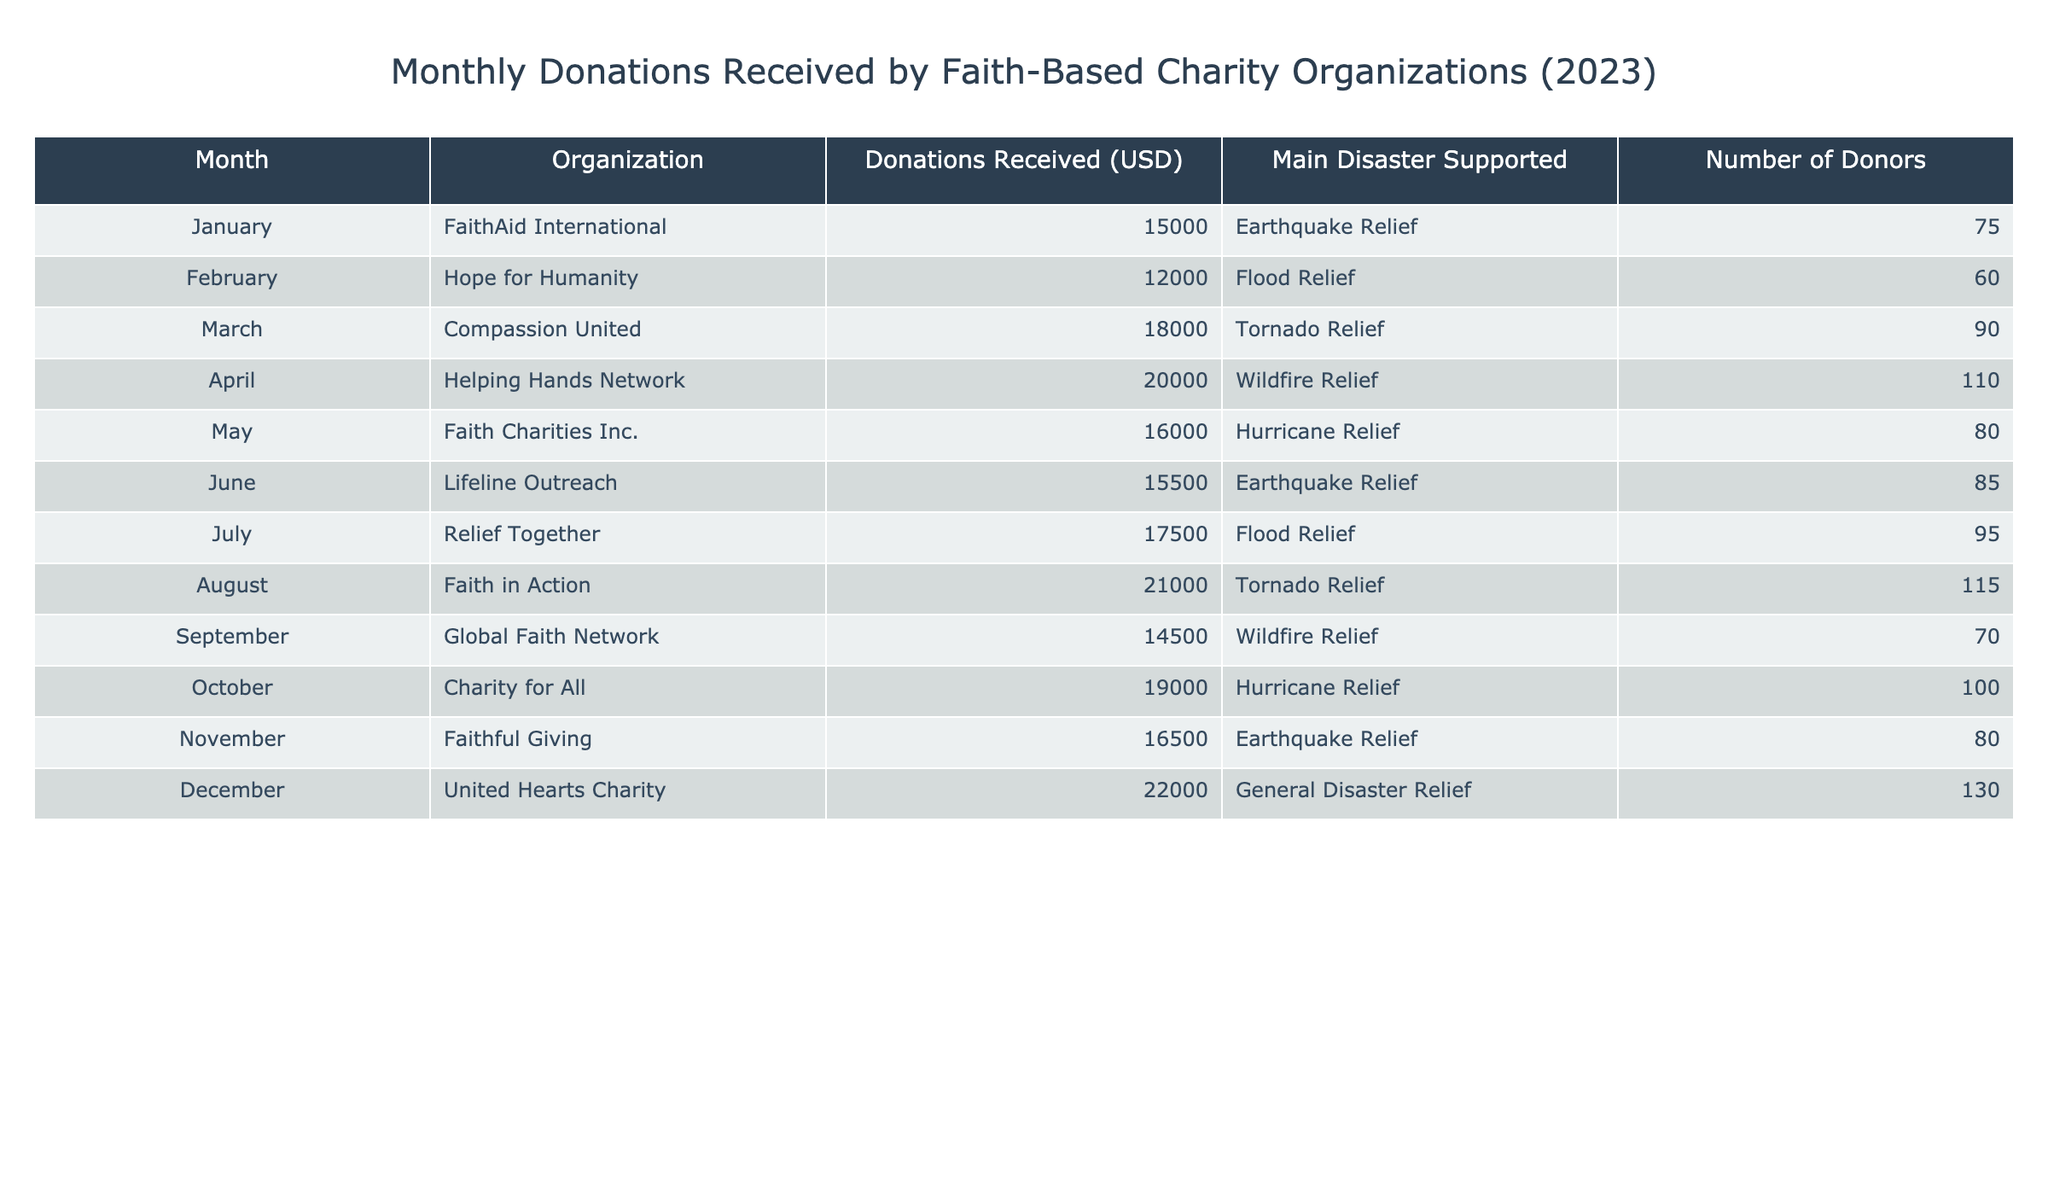What month saw the highest donations received? By looking at the Donations Received column, the month with the highest amount is December with $22,000.
Answer: December How many total donors contributed in March and July combined? In March, there were 90 donors and in July, there were 95 donors. Adding these together gives us 90 + 95 = 185.
Answer: 185 Did August's donations exceed those of February? August received $21,000 in donations and February received $12,000. Since $21,000 is greater than $12,000, the answer is yes.
Answer: Yes What is the average amount of donations received by the organizations in the first half of the year (January to June)? The donations for the first half are: January ($15,000), February ($12,000), March ($18,000), April ($20,000), May ($16,000), and June ($15,500). Summing these gives $15,000 + $12,000 + $18,000 + $20,000 + $16,000 + $15,500 = $96,500. There are 6 months, so the average is $96,500 / 6 = $16,083.33.
Answer: 16,083.33 What is the total donation amount for disaster relief related to earthquakes? The months that supported earthquake relief are January ($15,000), June ($15,500), and November ($16,500). Adding these donations gives $15,000 + $15,500 + $16,500 = $47,000.
Answer: 47,000 